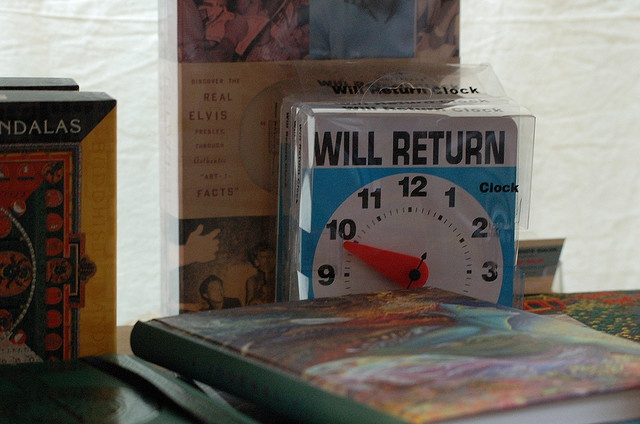Describe the objects in this image and their specific colors. I can see book in lightgray, gray, and black tones, book in lightgray, maroon, black, and gray tones, book in lightgray, black, maroon, and gray tones, clock in lightgray, gray, maroon, and black tones, and book in lightgray, darkgray, black, and gray tones in this image. 